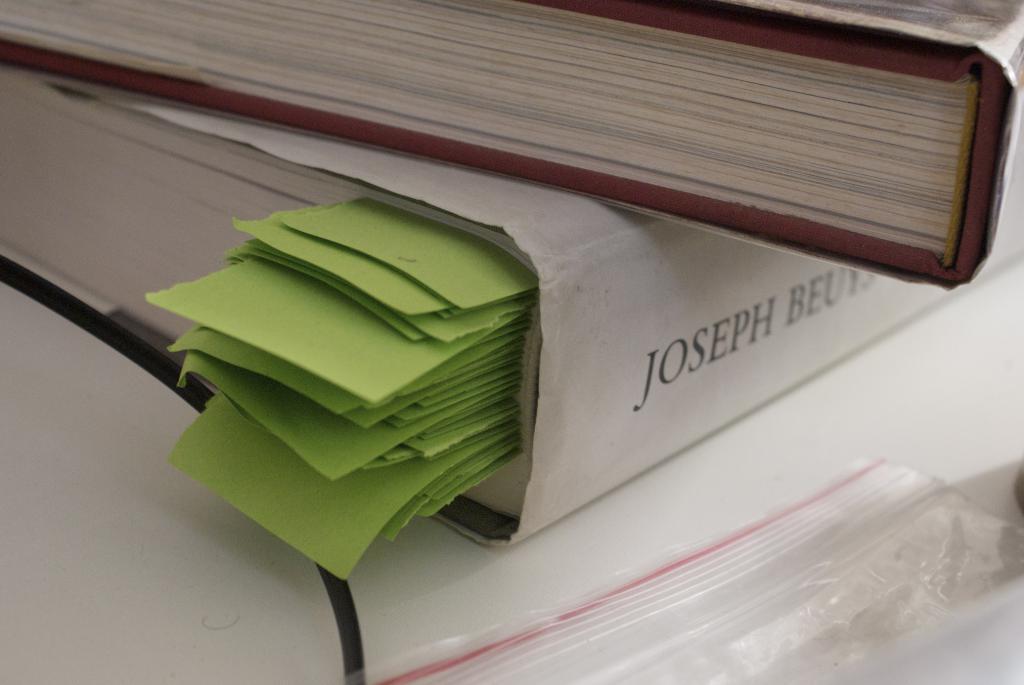What is the first name on the book?
Offer a terse response. Joseph. What is the first three letters of the second name?
Provide a succinct answer. Beu. 